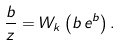Convert formula to latex. <formula><loc_0><loc_0><loc_500><loc_500>\frac { b } { z } = W _ { k } \left ( b \, e ^ { b } \right ) .</formula> 